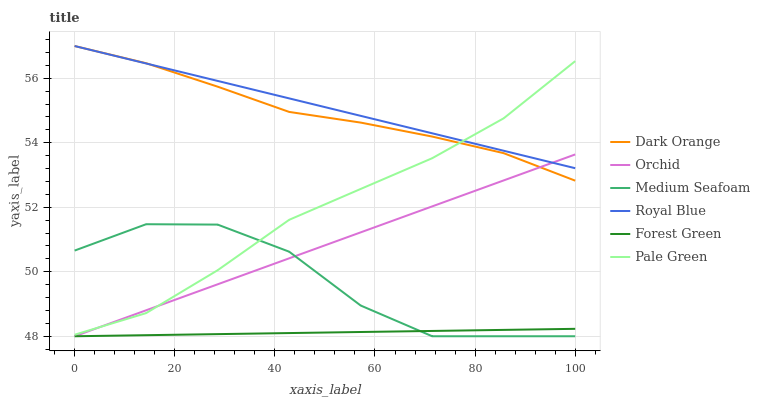Does Forest Green have the minimum area under the curve?
Answer yes or no. Yes. Does Royal Blue have the maximum area under the curve?
Answer yes or no. Yes. Does Royal Blue have the minimum area under the curve?
Answer yes or no. No. Does Forest Green have the maximum area under the curve?
Answer yes or no. No. Is Forest Green the smoothest?
Answer yes or no. Yes. Is Medium Seafoam the roughest?
Answer yes or no. Yes. Is Royal Blue the smoothest?
Answer yes or no. No. Is Royal Blue the roughest?
Answer yes or no. No. Does Forest Green have the lowest value?
Answer yes or no. Yes. Does Royal Blue have the lowest value?
Answer yes or no. No. Does Royal Blue have the highest value?
Answer yes or no. Yes. Does Forest Green have the highest value?
Answer yes or no. No. Is Medium Seafoam less than Dark Orange?
Answer yes or no. Yes. Is Royal Blue greater than Forest Green?
Answer yes or no. Yes. Does Orchid intersect Royal Blue?
Answer yes or no. Yes. Is Orchid less than Royal Blue?
Answer yes or no. No. Is Orchid greater than Royal Blue?
Answer yes or no. No. Does Medium Seafoam intersect Dark Orange?
Answer yes or no. No. 